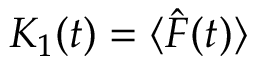Convert formula to latex. <formula><loc_0><loc_0><loc_500><loc_500>K _ { 1 } ( t ) = \langle \hat { F } ( t ) \rangle</formula> 